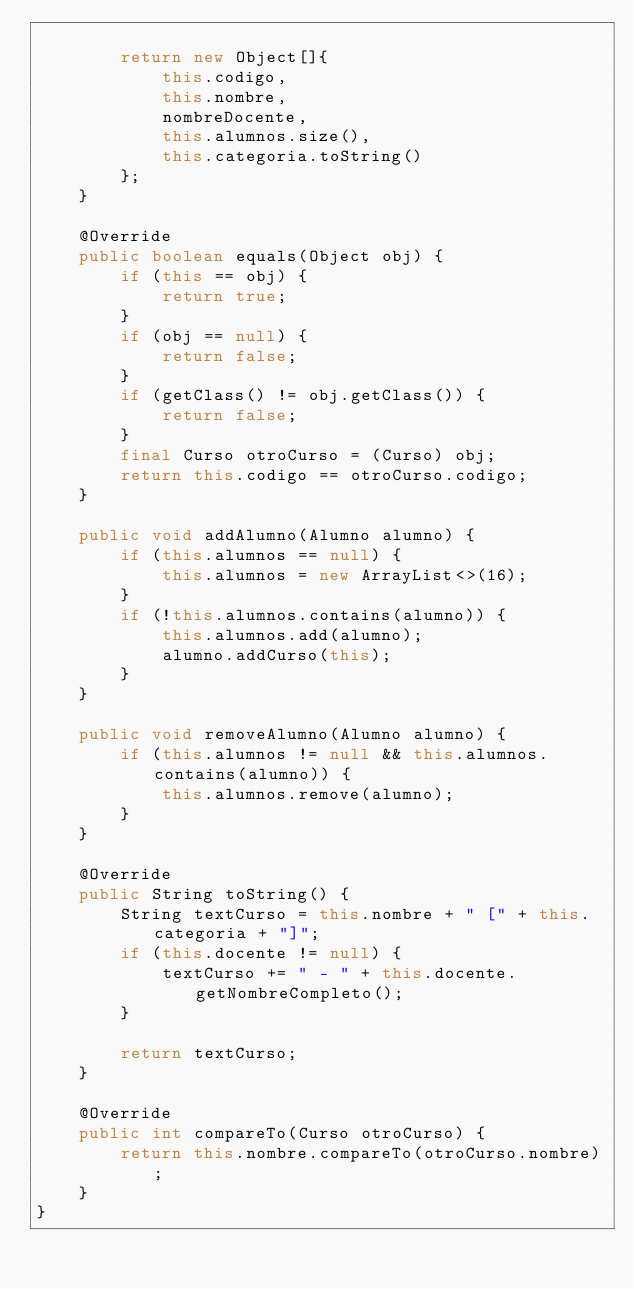<code> <loc_0><loc_0><loc_500><loc_500><_Java_>
        return new Object[]{
            this.codigo,
            this.nombre,
            nombreDocente,
            this.alumnos.size(),
            this.categoria.toString()
        };
    }

    @Override
    public boolean equals(Object obj) {
        if (this == obj) {
            return true;
        }
        if (obj == null) {
            return false;
        }
        if (getClass() != obj.getClass()) {
            return false;
        }
        final Curso otroCurso = (Curso) obj;
        return this.codigo == otroCurso.codigo;
    }

    public void addAlumno(Alumno alumno) {
        if (this.alumnos == null) {
            this.alumnos = new ArrayList<>(16);
        }
        if (!this.alumnos.contains(alumno)) {
            this.alumnos.add(alumno);
            alumno.addCurso(this);
        }
    }

    public void removeAlumno(Alumno alumno) {
        if (this.alumnos != null && this.alumnos.contains(alumno)) {
            this.alumnos.remove(alumno);
        }
    }

    @Override
    public String toString() {
        String textCurso = this.nombre + " [" + this.categoria + "]";
        if (this.docente != null) {
            textCurso += " - " + this.docente.getNombreCompleto();
        }

        return textCurso;
    }

    @Override
    public int compareTo(Curso otroCurso) {
        return this.nombre.compareTo(otroCurso.nombre);
    }
}
</code> 